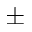<formula> <loc_0><loc_0><loc_500><loc_500>\pm</formula> 